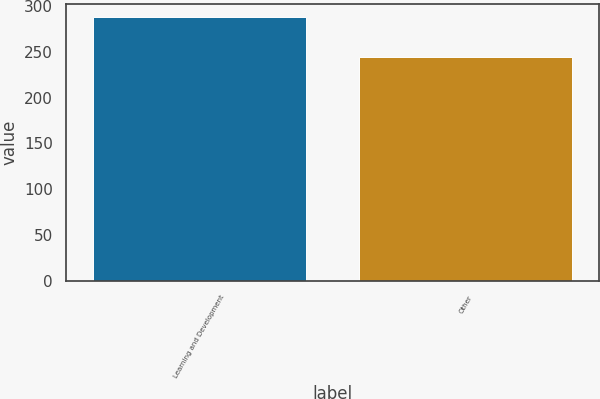Convert chart. <chart><loc_0><loc_0><loc_500><loc_500><bar_chart><fcel>Learning and Development<fcel>Other<nl><fcel>287.5<fcel>244.2<nl></chart> 